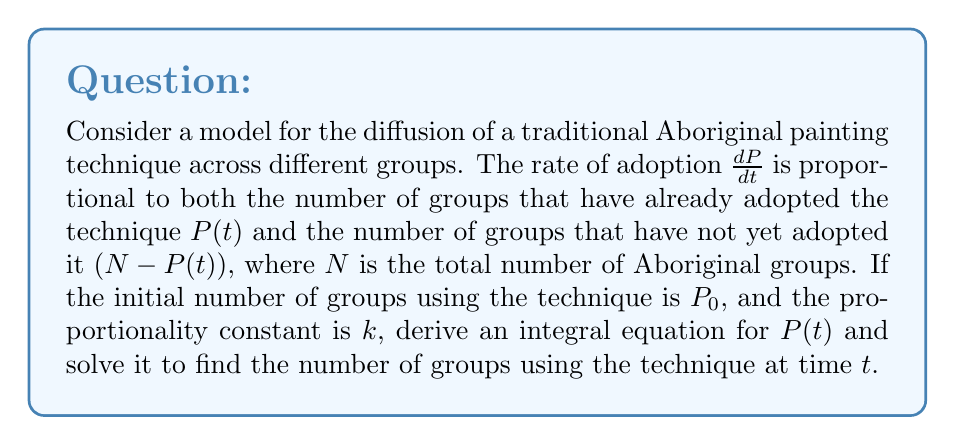Teach me how to tackle this problem. 1) First, we can express the rate of adoption as a differential equation:

   $$\frac{dP}{dt} = kP(t)(N - P(t))$$

2) To solve this, we need to separate the variables:

   $$\frac{dP}{P(N - P)} = kdt$$

3) Integrate both sides:

   $$\int \frac{dP}{P(N - P)} = \int kdt$$

4) The left side can be decomposed using partial fractions:

   $$\int (\frac{1}{NP} + \frac{1}{N(N-P)}) dP = kt + C$$

5) Integrating:

   $$\frac{1}{N} [\ln|P| - \ln|N-P|] = kt + C$$

6) Simplify:

   $$\ln|\frac{P}{N-P}| = Nkt + C$$

7) Apply the initial condition: At $t=0$, $P = P_0$:

   $$\ln|\frac{P_0}{N-P_0}| = C$$

8) Subtract this from the general solution:

   $$\ln|\frac{P}{N-P}| - \ln|\frac{P_0}{N-P_0}| = Nkt$$

9) Simplify:

   $$\ln|\frac{P(N-P_0)}{P_0(N-P)}| = Nkt$$

10) Take the exponential of both sides:

    $$\frac{P(N-P_0)}{P_0(N-P)} = e^{Nkt}$$

11) Solve for $P$:

    $$P = \frac{NP_0e^{Nkt}}{P_0e^{Nkt} + N - P_0}$$

This is the solution for $P(t)$, representing the number of groups using the technique at time $t$.
Answer: $$P(t) = \frac{NP_0e^{Nkt}}{P_0e^{Nkt} + N - P_0}$$ 